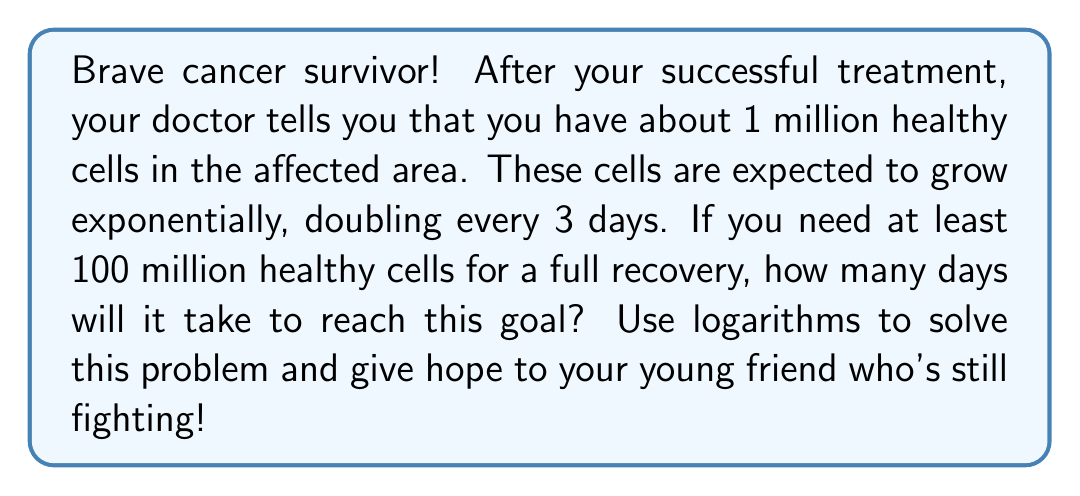Help me with this question. Let's approach this step-by-step:

1) We start with 1 million cells and need to reach 100 million cells.

2) The cells double every 3 days. We can express this as an exponential function:

   $f(t) = 1,000,000 \cdot 2^{\frac{t}{3}}$

   Where $t$ is the number of days.

3) We want to find $t$ when $f(t) = 100,000,000$:

   $100,000,000 = 1,000,000 \cdot 2^{\frac{t}{3}}$

4) Divide both sides by 1,000,000:

   $100 = 2^{\frac{t}{3}}$

5) Now, we can use logarithms to solve for $t$. Let's use log base 2:

   $\log_2(100) = \frac{t}{3}$

6) Multiply both sides by 3:

   $3 \log_2(100) = t$

7) We can calculate this:
   
   $\log_2(100) = \frac{\log(100)}{\log(2)} \approx 6.64386$

   $t = 3 \cdot 6.64386 \approx 19.93158$

8) Since we can't have a fraction of a day, we round up to the next whole number.
Answer: It will take 20 days for the number of healthy cells to reach 100 million. 